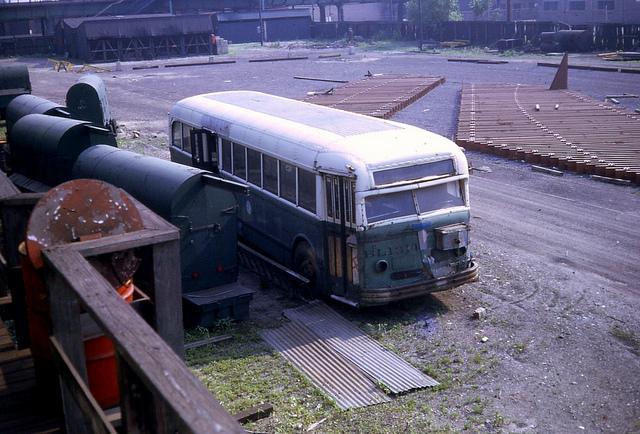How many buses are there?
Give a very brief answer. 1. 